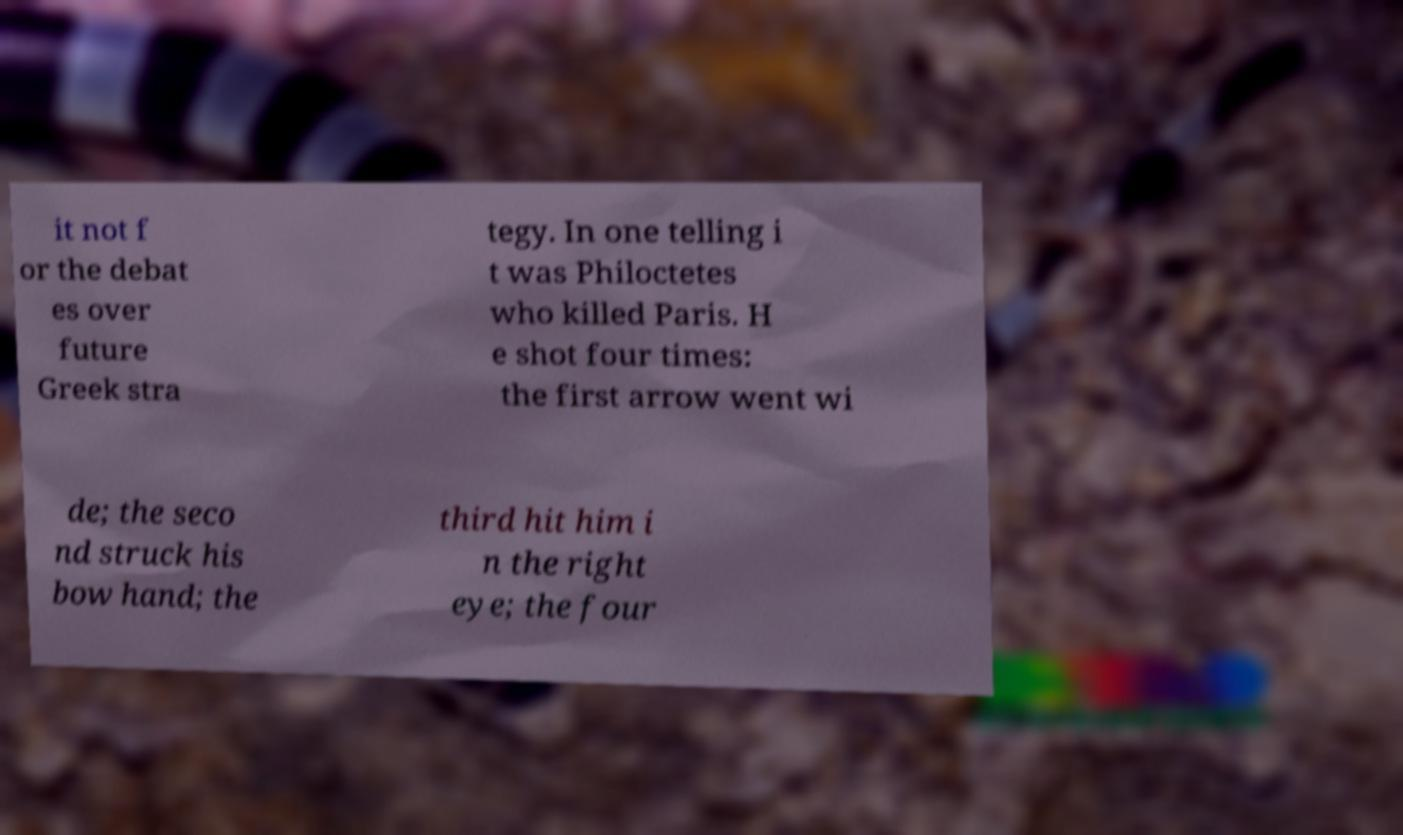I need the written content from this picture converted into text. Can you do that? it not f or the debat es over future Greek stra tegy. In one telling i t was Philoctetes who killed Paris. H e shot four times: the first arrow went wi de; the seco nd struck his bow hand; the third hit him i n the right eye; the four 